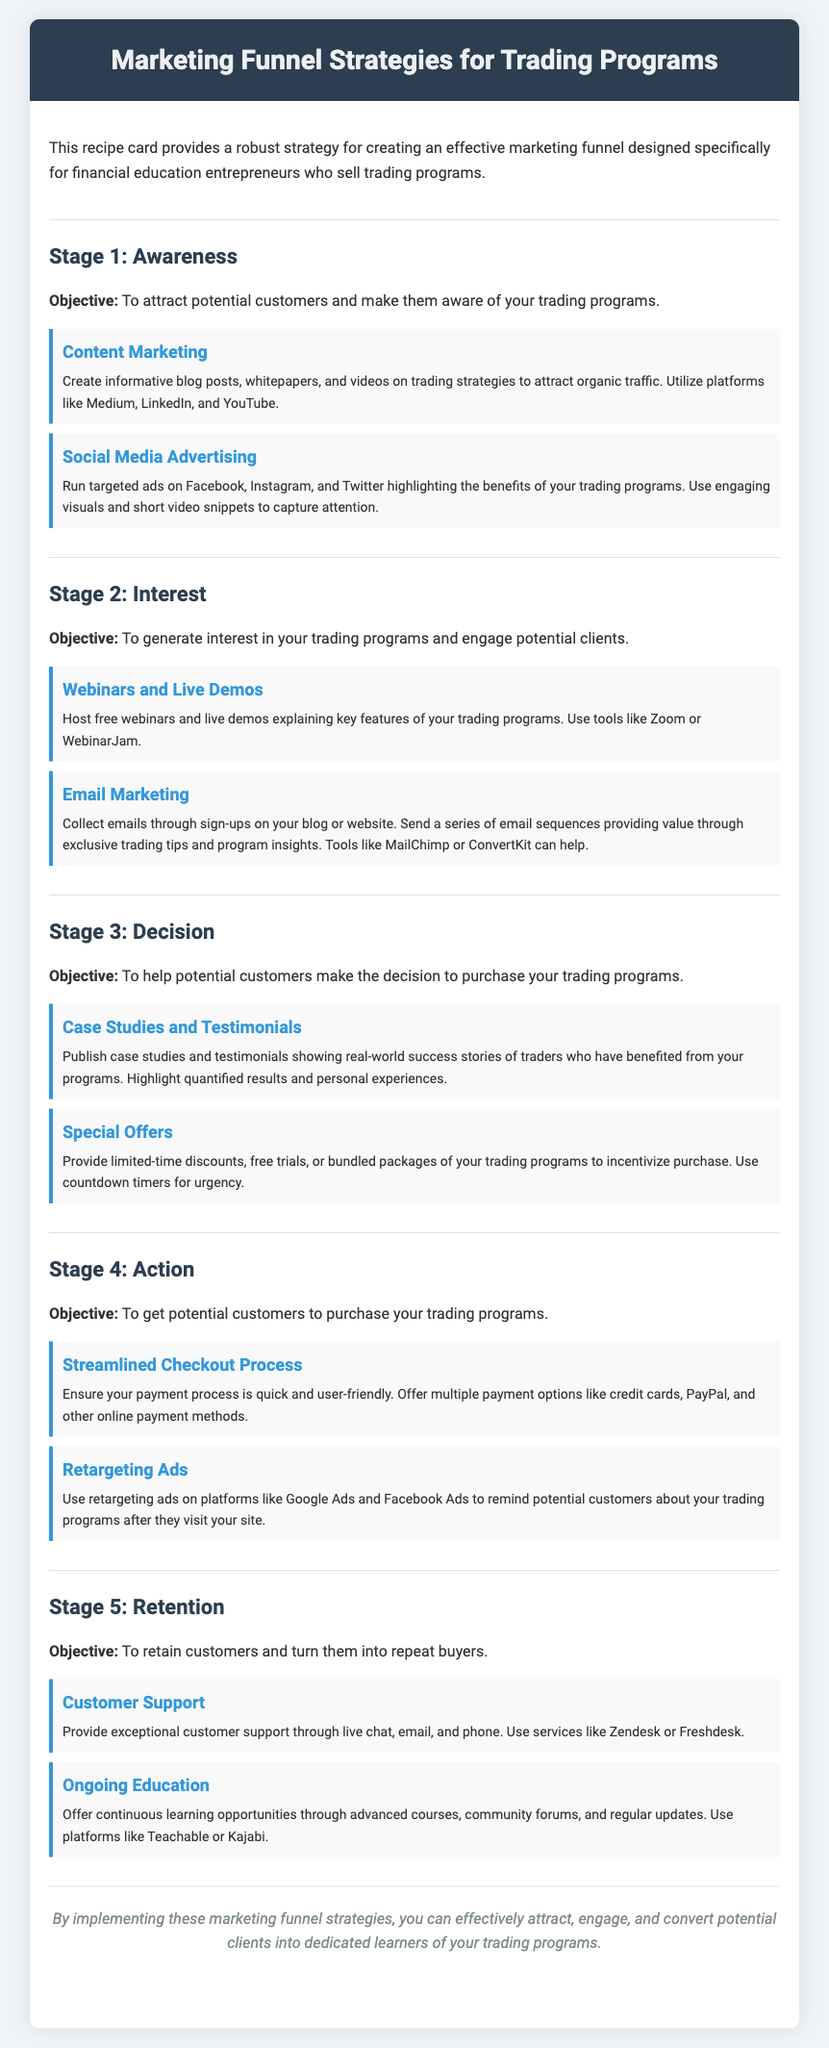What is the title of the document? The title of the document is provided in the header section.
Answer: Marketing Funnel Strategies for Trading Programs What is the objective of Stage 1? The objective of Stage 1 is outlined in the section description.
Answer: To attract potential customers and make them aware of your trading programs Which strategy focuses on informative content creation? The strategy name is mentioned in the Awareness stage.
Answer: Content Marketing What tool can be used for hosting webinars? The document lists tools for specific strategies, detailing a recommended tool for webinars.
Answer: Zoom What does the special offers strategy aim to provide? The document mentions the intent behind the special offers strategy in Stage 3.
Answer: Limited-time discounts What is the focus of the retention strategy? The document describes the main goal of the retention stage.
Answer: To retain customers and turn them into repeat buyers Which strategy highlights real-world success? The strategy is identified in Stage 3, focusing on customer experiences.
Answer: Case Studies and Testimonials What is a recommended platform for ongoing education? A specific platform for providing educational resources is mentioned in the Retention stage.
Answer: Teachable 